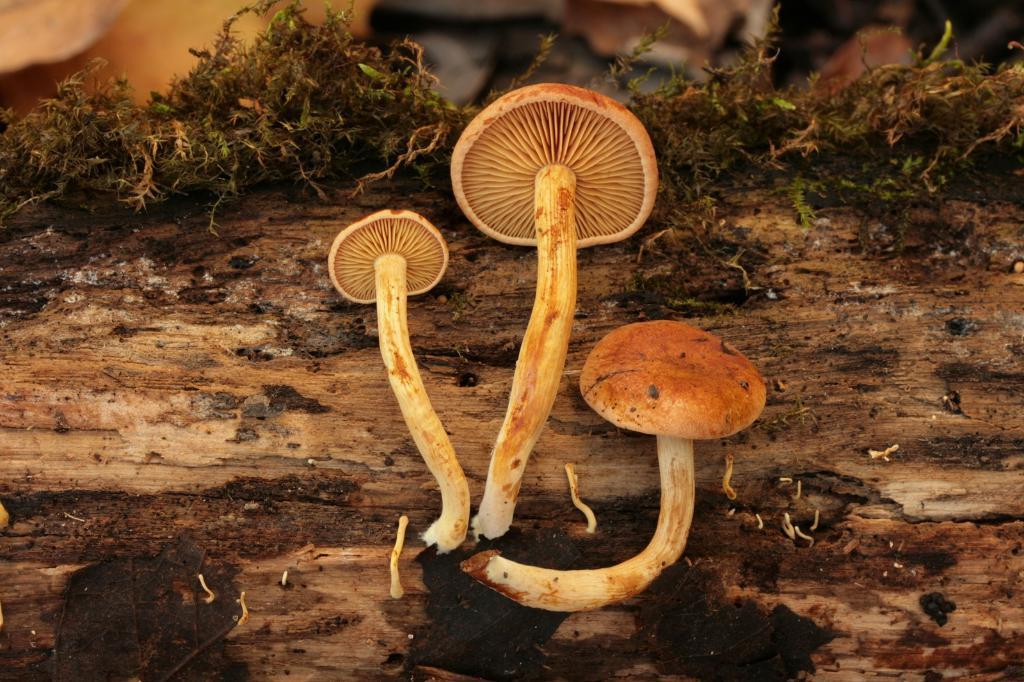What is the primary setting of the image? The image shows the ground. What type of vegetation can be seen growing on the ground? There are mushrooms in the image. How many cakes are visible in the image? There are no cakes present in the image; it only shows mushrooms growing on the ground. 